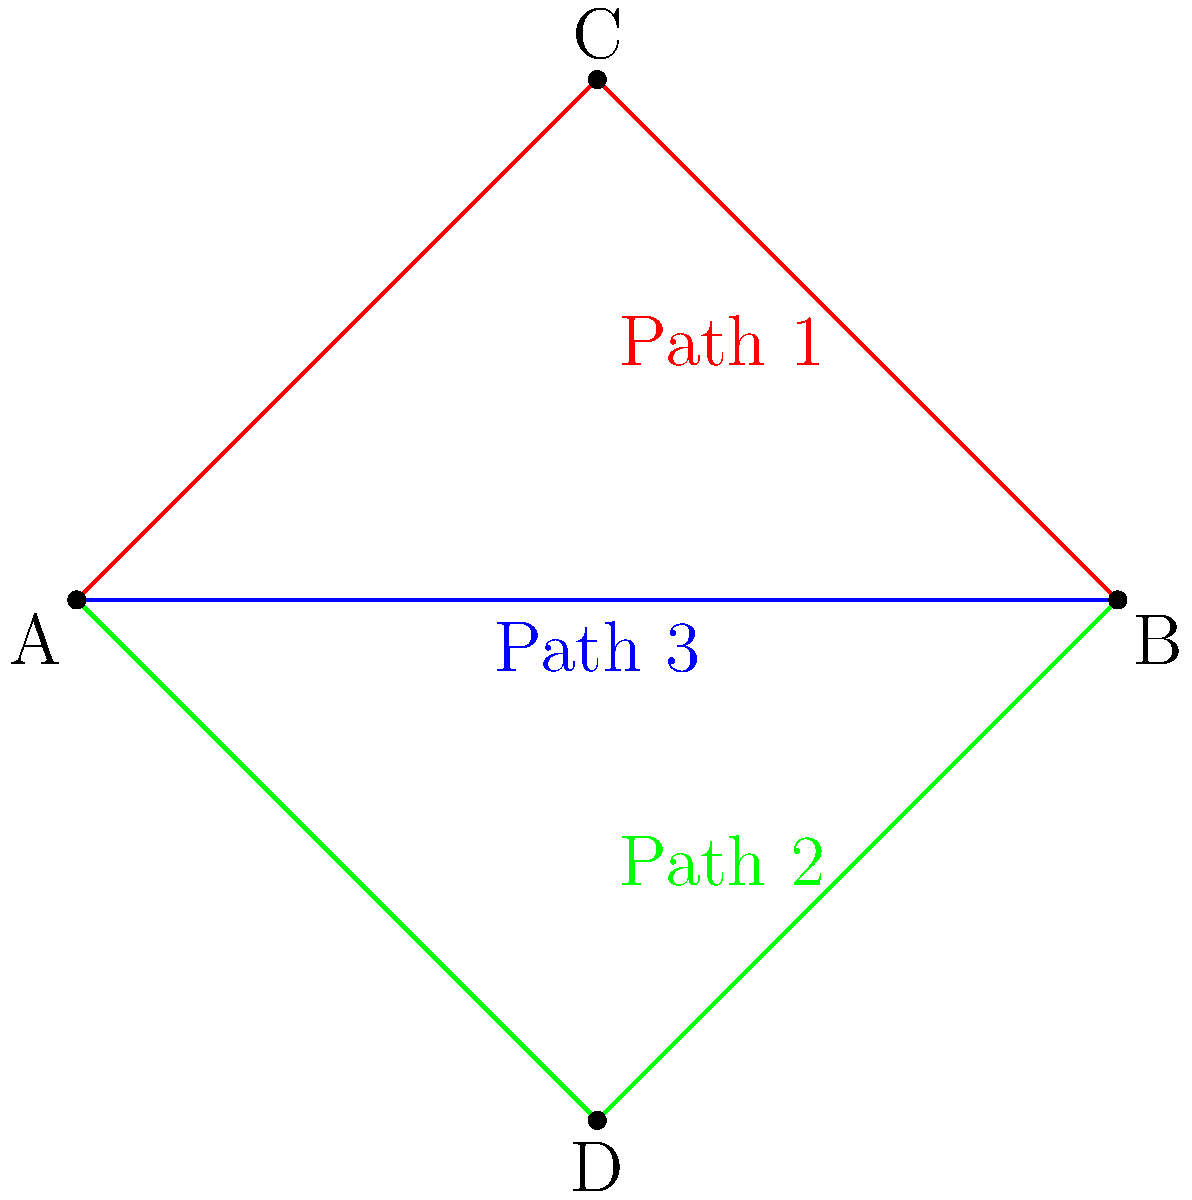In a large-scale international project, you need to design redundant network paths between two major data centers (A and B) across different countries. The diagram shows three possible paths: Path 1 (A-C-B), Path 2 (A-D-B), and Path 3 (A-B). Each path has a different cost and latency. Path 1 costs €500,000 with 50ms latency, Path 2 costs €600,000 with 40ms latency, and Path 3 costs €800,000 with 30ms latency. The project requires at least two paths with a combined latency not exceeding 100ms. What is the optimal combination of paths to implement, considering both cost and latency requirements? To solve this problem, we need to follow these steps:

1. Identify the constraints:
   - At least two paths are required
   - Combined latency should not exceed 100ms

2. List all possible combinations of two paths:
   - Path 1 + Path 2
   - Path 1 + Path 3
   - Path 2 + Path 3

3. Calculate the combined latency for each combination:
   - Path 1 + Path 2: 50ms + 40ms = 90ms
   - Path 1 + Path 3: 50ms + 30ms = 80ms
   - Path 2 + Path 3: 40ms + 30ms = 70ms

4. Eliminate combinations that don't meet the latency requirement:
   All combinations meet the requirement (< 100ms)

5. Calculate the total cost for each valid combination:
   - Path 1 + Path 2: €500,000 + €600,000 = €1,100,000
   - Path 1 + Path 3: €500,000 + €800,000 = €1,300,000
   - Path 2 + Path 3: €600,000 + €800,000 = €1,400,000

6. Choose the combination with the lowest total cost:
   Path 1 + Path 2 has the lowest total cost of €1,100,000

Therefore, the optimal combination of paths to implement, considering both cost and latency requirements, is Path 1 (A-C-B) and Path 2 (A-D-B).
Answer: Path 1 (A-C-B) and Path 2 (A-D-B) 